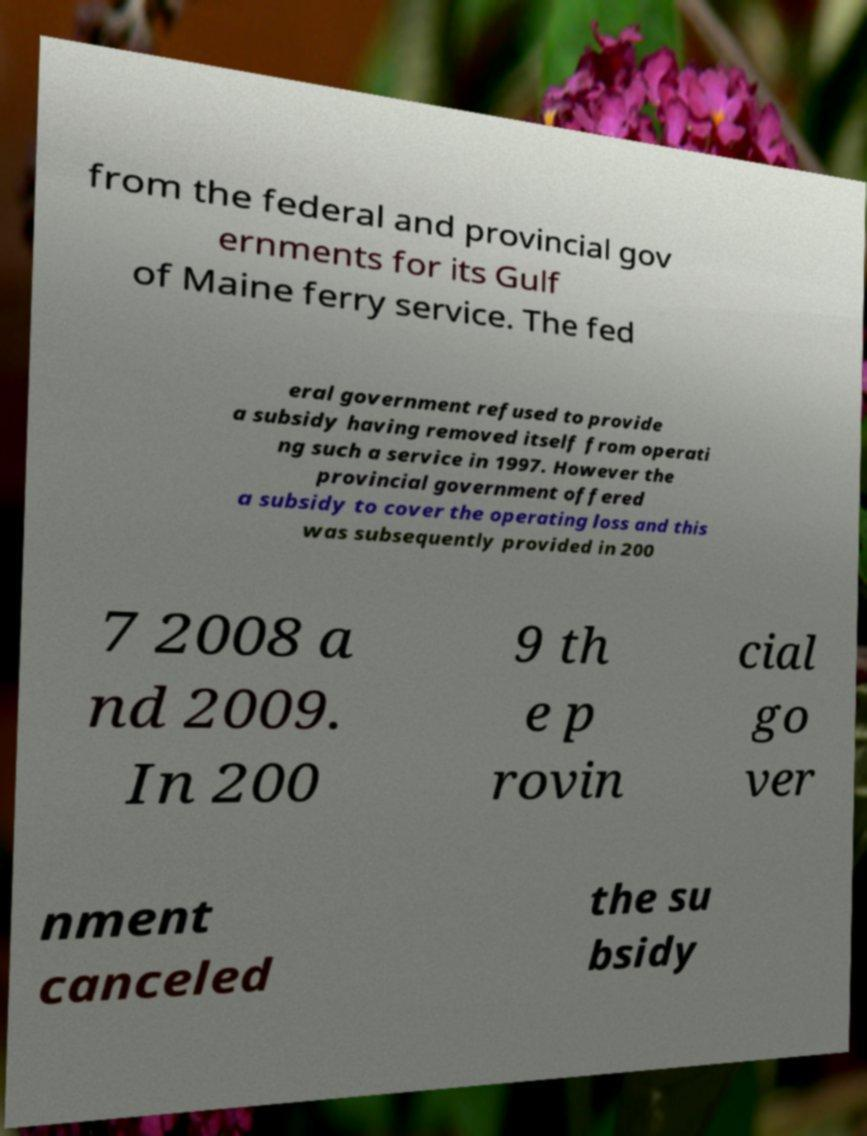Could you extract and type out the text from this image? from the federal and provincial gov ernments for its Gulf of Maine ferry service. The fed eral government refused to provide a subsidy having removed itself from operati ng such a service in 1997. However the provincial government offered a subsidy to cover the operating loss and this was subsequently provided in 200 7 2008 a nd 2009. In 200 9 th e p rovin cial go ver nment canceled the su bsidy 